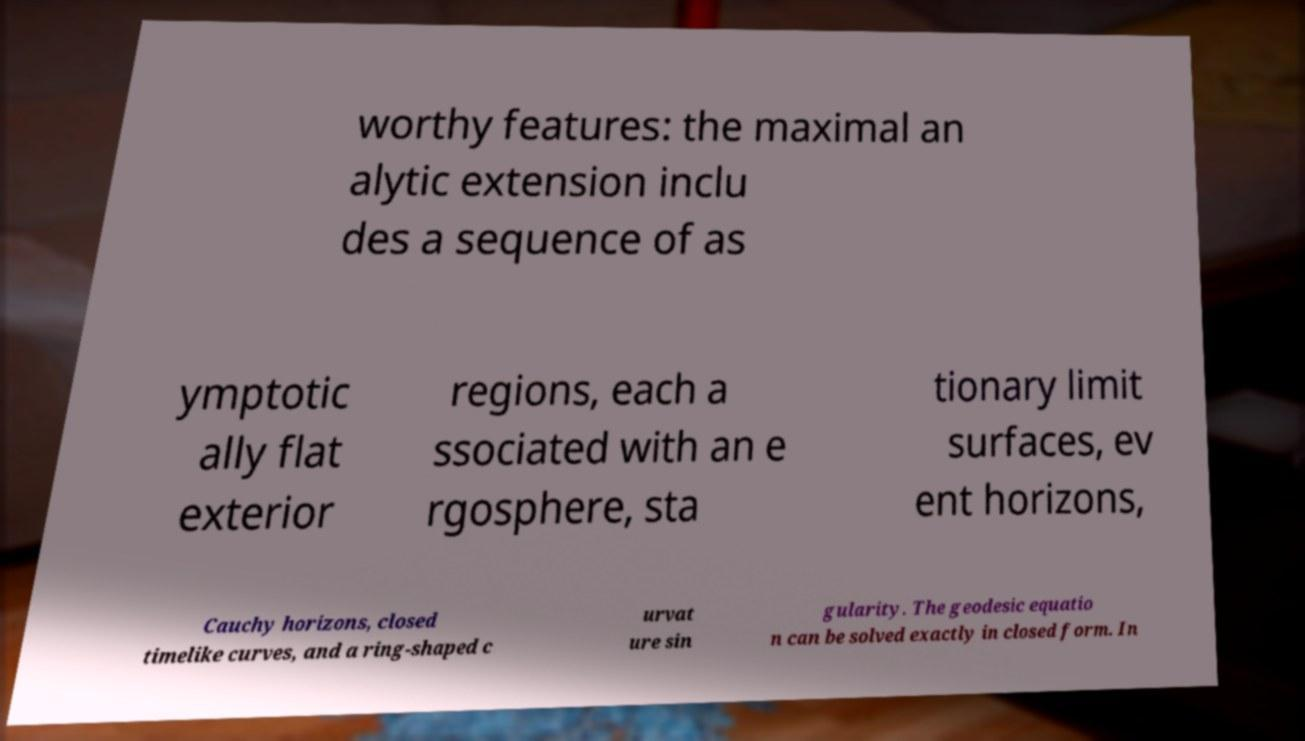For documentation purposes, I need the text within this image transcribed. Could you provide that? worthy features: the maximal an alytic extension inclu des a sequence of as ymptotic ally flat exterior regions, each a ssociated with an e rgosphere, sta tionary limit surfaces, ev ent horizons, Cauchy horizons, closed timelike curves, and a ring-shaped c urvat ure sin gularity. The geodesic equatio n can be solved exactly in closed form. In 